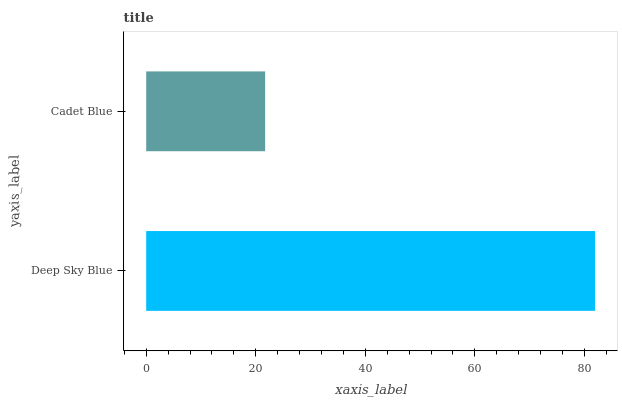Is Cadet Blue the minimum?
Answer yes or no. Yes. Is Deep Sky Blue the maximum?
Answer yes or no. Yes. Is Cadet Blue the maximum?
Answer yes or no. No. Is Deep Sky Blue greater than Cadet Blue?
Answer yes or no. Yes. Is Cadet Blue less than Deep Sky Blue?
Answer yes or no. Yes. Is Cadet Blue greater than Deep Sky Blue?
Answer yes or no. No. Is Deep Sky Blue less than Cadet Blue?
Answer yes or no. No. Is Deep Sky Blue the high median?
Answer yes or no. Yes. Is Cadet Blue the low median?
Answer yes or no. Yes. Is Cadet Blue the high median?
Answer yes or no. No. Is Deep Sky Blue the low median?
Answer yes or no. No. 